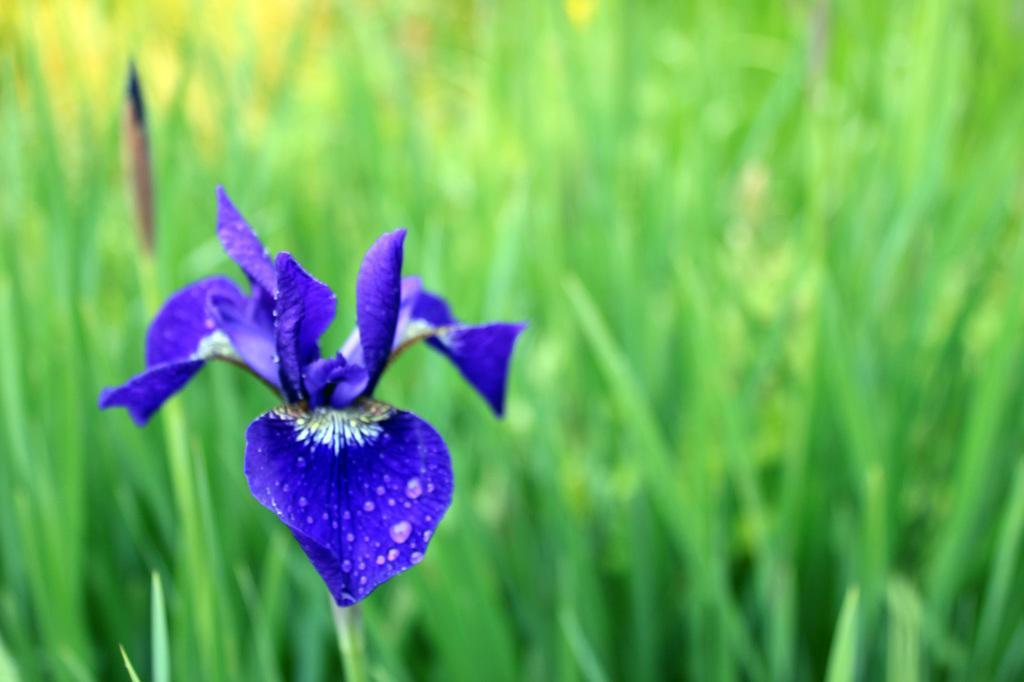Describe this image in one or two sentences. In this image, we can see a flower with water droplets. The background of the image is blur and greenery. 